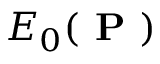<formula> <loc_0><loc_0><loc_500><loc_500>E _ { 0 } ( P )</formula> 